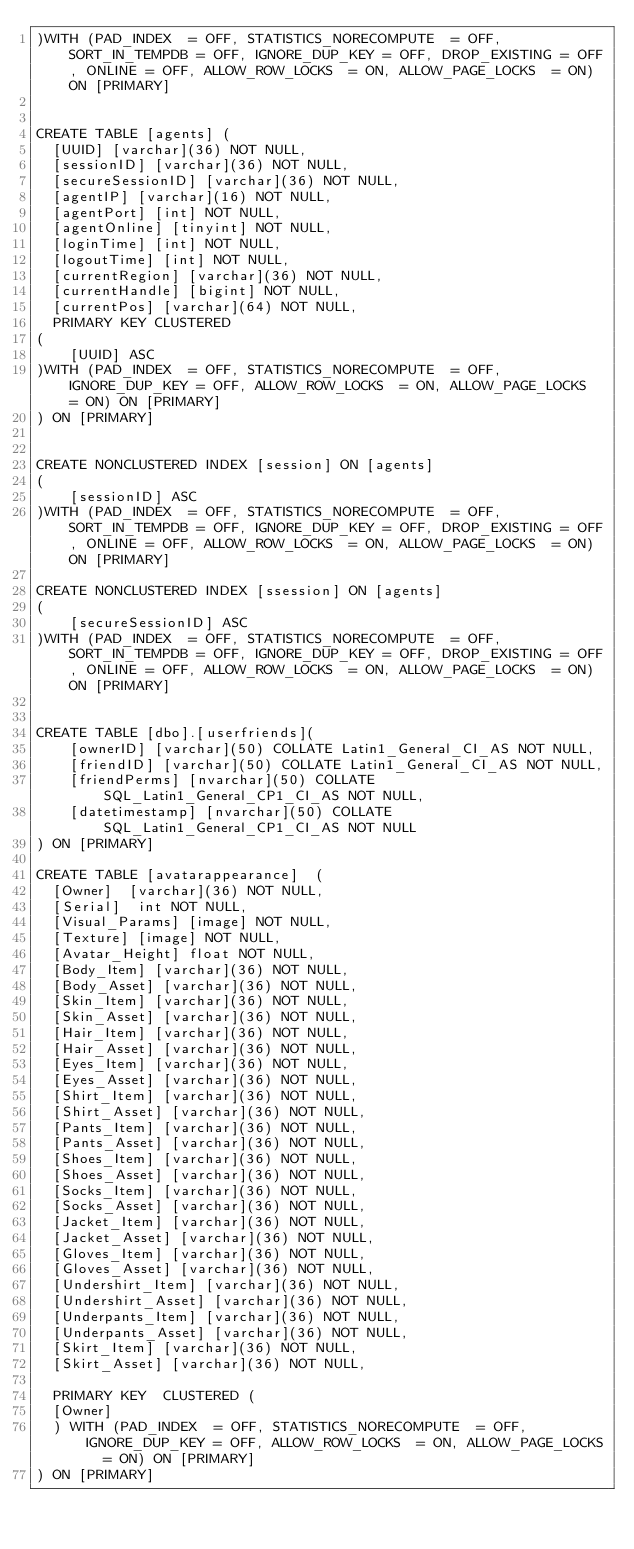<code> <loc_0><loc_0><loc_500><loc_500><_SQL_>)WITH (PAD_INDEX  = OFF, STATISTICS_NORECOMPUTE  = OFF, SORT_IN_TEMPDB = OFF, IGNORE_DUP_KEY = OFF, DROP_EXISTING = OFF, ONLINE = OFF, ALLOW_ROW_LOCKS  = ON, ALLOW_PAGE_LOCKS  = ON) ON [PRIMARY]


CREATE TABLE [agents] (
  [UUID] [varchar](36) NOT NULL,
  [sessionID] [varchar](36) NOT NULL,
  [secureSessionID] [varchar](36) NOT NULL,
  [agentIP] [varchar](16) NOT NULL,
  [agentPort] [int] NOT NULL,
  [agentOnline] [tinyint] NOT NULL,
  [loginTime] [int] NOT NULL,
  [logoutTime] [int] NOT NULL,
  [currentRegion] [varchar](36) NOT NULL,
  [currentHandle] [bigint] NOT NULL,
  [currentPos] [varchar](64) NOT NULL,
  PRIMARY KEY CLUSTERED
(
	[UUID] ASC
)WITH (PAD_INDEX  = OFF, STATISTICS_NORECOMPUTE  = OFF, IGNORE_DUP_KEY = OFF, ALLOW_ROW_LOCKS  = ON, ALLOW_PAGE_LOCKS  = ON) ON [PRIMARY]
) ON [PRIMARY]


CREATE NONCLUSTERED INDEX [session] ON [agents]
(
	[sessionID] ASC
)WITH (PAD_INDEX  = OFF, STATISTICS_NORECOMPUTE  = OFF, SORT_IN_TEMPDB = OFF, IGNORE_DUP_KEY = OFF, DROP_EXISTING = OFF, ONLINE = OFF, ALLOW_ROW_LOCKS  = ON, ALLOW_PAGE_LOCKS  = ON) ON [PRIMARY]

CREATE NONCLUSTERED INDEX [ssession] ON [agents]
(
	[secureSessionID] ASC
)WITH (PAD_INDEX  = OFF, STATISTICS_NORECOMPUTE  = OFF, SORT_IN_TEMPDB = OFF, IGNORE_DUP_KEY = OFF, DROP_EXISTING = OFF, ONLINE = OFF, ALLOW_ROW_LOCKS  = ON, ALLOW_PAGE_LOCKS  = ON) ON [PRIMARY]


CREATE TABLE [dbo].[userfriends](
	[ownerID] [varchar](50) COLLATE Latin1_General_CI_AS NOT NULL,
	[friendID] [varchar](50) COLLATE Latin1_General_CI_AS NOT NULL,
	[friendPerms] [nvarchar](50) COLLATE SQL_Latin1_General_CP1_CI_AS NOT NULL,
	[datetimestamp] [nvarchar](50) COLLATE SQL_Latin1_General_CP1_CI_AS NOT NULL
) ON [PRIMARY]

CREATE TABLE [avatarappearance]  (
  [Owner]  [varchar](36) NOT NULL,
  [Serial]  int NOT NULL,
  [Visual_Params] [image] NOT NULL,
  [Texture] [image] NOT NULL,
  [Avatar_Height] float NOT NULL,
  [Body_Item] [varchar](36) NOT NULL,
  [Body_Asset] [varchar](36) NOT NULL,
  [Skin_Item] [varchar](36) NOT NULL,
  [Skin_Asset] [varchar](36) NOT NULL,
  [Hair_Item] [varchar](36) NOT NULL,
  [Hair_Asset] [varchar](36) NOT NULL,
  [Eyes_Item] [varchar](36) NOT NULL,
  [Eyes_Asset] [varchar](36) NOT NULL,
  [Shirt_Item] [varchar](36) NOT NULL,
  [Shirt_Asset] [varchar](36) NOT NULL,
  [Pants_Item] [varchar](36) NOT NULL,
  [Pants_Asset] [varchar](36) NOT NULL,
  [Shoes_Item] [varchar](36) NOT NULL,
  [Shoes_Asset] [varchar](36) NOT NULL,
  [Socks_Item] [varchar](36) NOT NULL,
  [Socks_Asset] [varchar](36) NOT NULL,
  [Jacket_Item] [varchar](36) NOT NULL,
  [Jacket_Asset] [varchar](36) NOT NULL,
  [Gloves_Item] [varchar](36) NOT NULL,
  [Gloves_Asset] [varchar](36) NOT NULL,
  [Undershirt_Item] [varchar](36) NOT NULL,
  [Undershirt_Asset] [varchar](36) NOT NULL,
  [Underpants_Item] [varchar](36) NOT NULL,
  [Underpants_Asset] [varchar](36) NOT NULL,
  [Skirt_Item] [varchar](36) NOT NULL,
  [Skirt_Asset] [varchar](36) NOT NULL,

  PRIMARY KEY  CLUSTERED (
  [Owner]
  ) WITH (PAD_INDEX  = OFF, STATISTICS_NORECOMPUTE  = OFF, IGNORE_DUP_KEY = OFF, ALLOW_ROW_LOCKS  = ON, ALLOW_PAGE_LOCKS  = ON) ON [PRIMARY]
) ON [PRIMARY]
</code> 